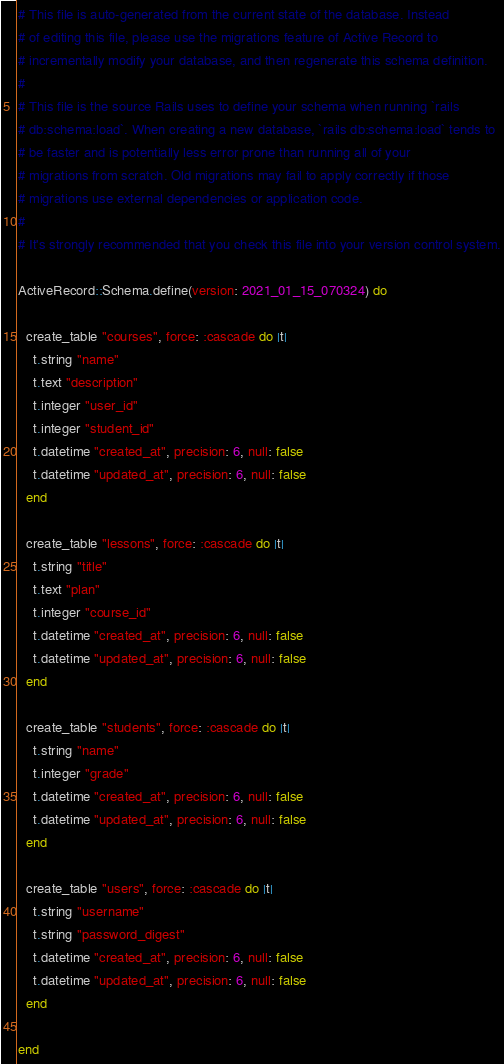Convert code to text. <code><loc_0><loc_0><loc_500><loc_500><_Ruby_># This file is auto-generated from the current state of the database. Instead
# of editing this file, please use the migrations feature of Active Record to
# incrementally modify your database, and then regenerate this schema definition.
#
# This file is the source Rails uses to define your schema when running `rails
# db:schema:load`. When creating a new database, `rails db:schema:load` tends to
# be faster and is potentially less error prone than running all of your
# migrations from scratch. Old migrations may fail to apply correctly if those
# migrations use external dependencies or application code.
#
# It's strongly recommended that you check this file into your version control system.

ActiveRecord::Schema.define(version: 2021_01_15_070324) do

  create_table "courses", force: :cascade do |t|
    t.string "name"
    t.text "description"
    t.integer "user_id"
    t.integer "student_id"
    t.datetime "created_at", precision: 6, null: false
    t.datetime "updated_at", precision: 6, null: false
  end

  create_table "lessons", force: :cascade do |t|
    t.string "title"
    t.text "plan"
    t.integer "course_id"
    t.datetime "created_at", precision: 6, null: false
    t.datetime "updated_at", precision: 6, null: false
  end

  create_table "students", force: :cascade do |t|
    t.string "name"
    t.integer "grade"
    t.datetime "created_at", precision: 6, null: false
    t.datetime "updated_at", precision: 6, null: false
  end

  create_table "users", force: :cascade do |t|
    t.string "username"
    t.string "password_digest"
    t.datetime "created_at", precision: 6, null: false
    t.datetime "updated_at", precision: 6, null: false
  end

end
</code> 